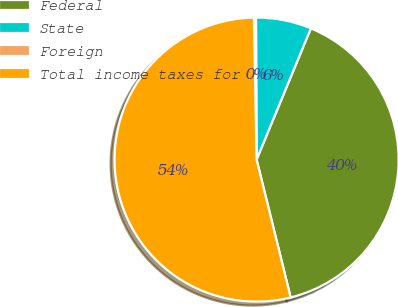<chart> <loc_0><loc_0><loc_500><loc_500><pie_chart><fcel>Federal<fcel>State<fcel>Foreign<fcel>Total income taxes for<nl><fcel>39.9%<fcel>6.31%<fcel>0.23%<fcel>53.56%<nl></chart> 